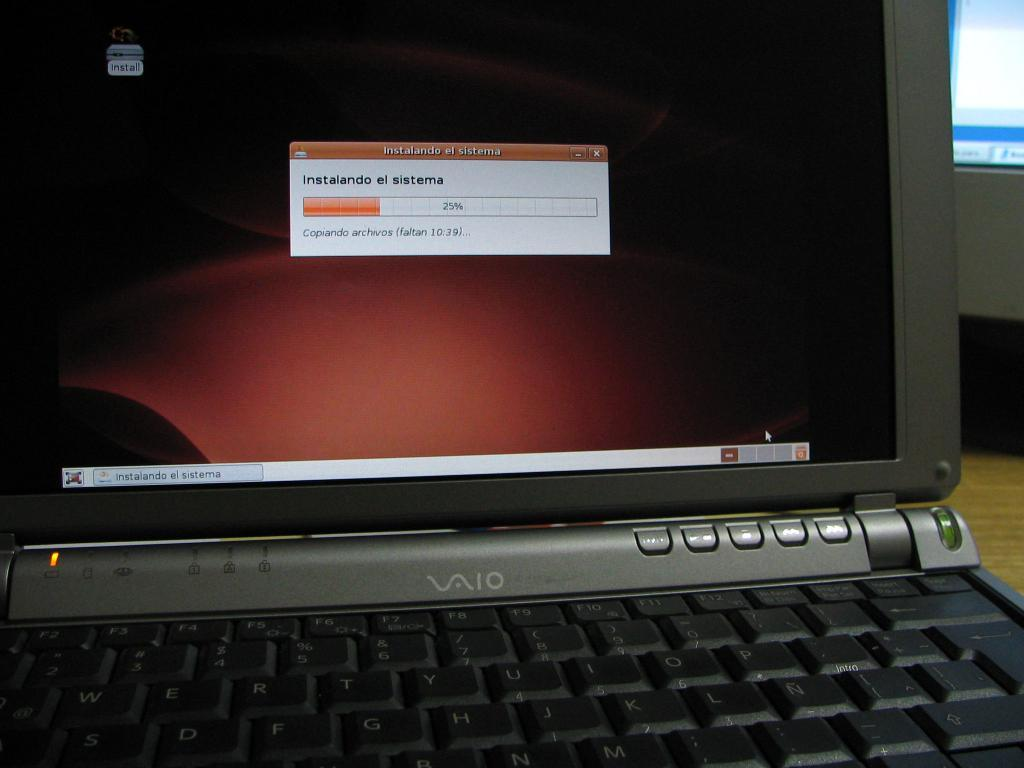<image>
Give a short and clear explanation of the subsequent image. a Vaio laptop is displaying the progress of some operation in a foreign language 